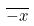Convert formula to latex. <formula><loc_0><loc_0><loc_500><loc_500>\overline { - x }</formula> 